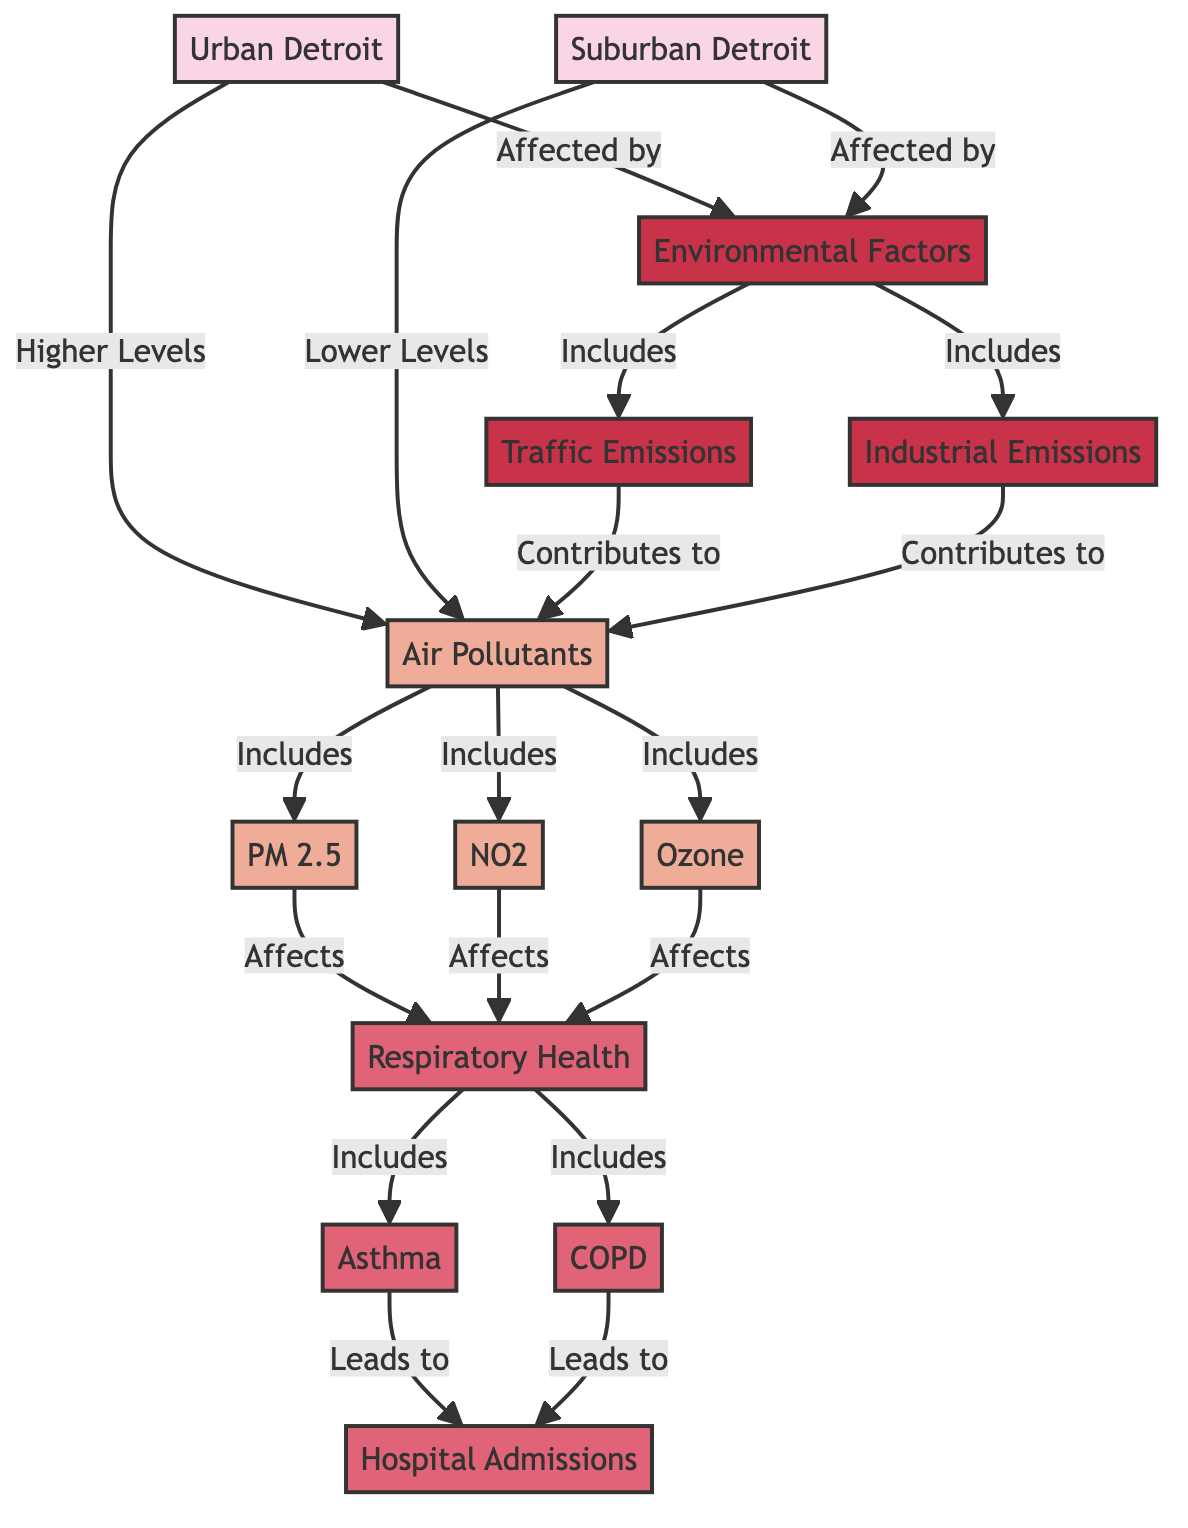What are the two locations compared in the diagram? The diagram compares two locations: Urban Detroit and Suburban Detroit, which are explicitly labeled at the start of the diagram.
Answer: Urban Detroit, Suburban Detroit Which air pollutants are included in the diagram? The diagram specifies three air pollutants: PM 2.5, NO2, and Ozone, shown as components of the node "Air Pollutants."
Answer: PM 2.5, NO2, Ozone How do air pollutants affect respiratory health? The diagram shows an arrow from "Air Pollutants" to "Respiratory Health," indicating that air pollutants directly affect respiratory health.
Answer: Affects What respiratory health conditions are mentioned? The diagram mentions two respiratory health conditions that are affected: Asthma and COPD, which are listed under the "Respiratory Health" node.
Answer: Asthma, COPD What contributes to the air pollutants in both locations? The diagram connects "Environmental Factors" to "Air Pollutants" and includes "Traffic Emissions" and "Industrial Emissions," indicating they contribute to air pollutants.
Answer: Traffic Emissions, Industrial Emissions How does urban Detroit's air quality compare to suburban Detroit? The diagram indicates that Urban Detroit has higher levels of air pollutants compared to Suburban Detroit, as shown by the labeled arrows leading from the locations to the "Air Pollutants" node.
Answer: Higher Levels What leads to hospital admissions according to the diagram? The flowchart shows that asthma and COPD lead to hospital admissions, making them key health outcomes linked to respiratory health.
Answer: Leads to What environmental factors are common to both urban and suburban areas? The diagram shows that both Urban and Suburban Detroit are affected by "Environmental Factors," which include traffic emissions and industrial emissions.
Answer: Environmental Factors How many air pollutants are illustrated in the diagram? The diagram specifies three air pollutants: PM 2.5, NO2, and Ozone, counting them gives a total of three air pollutants.
Answer: 3 